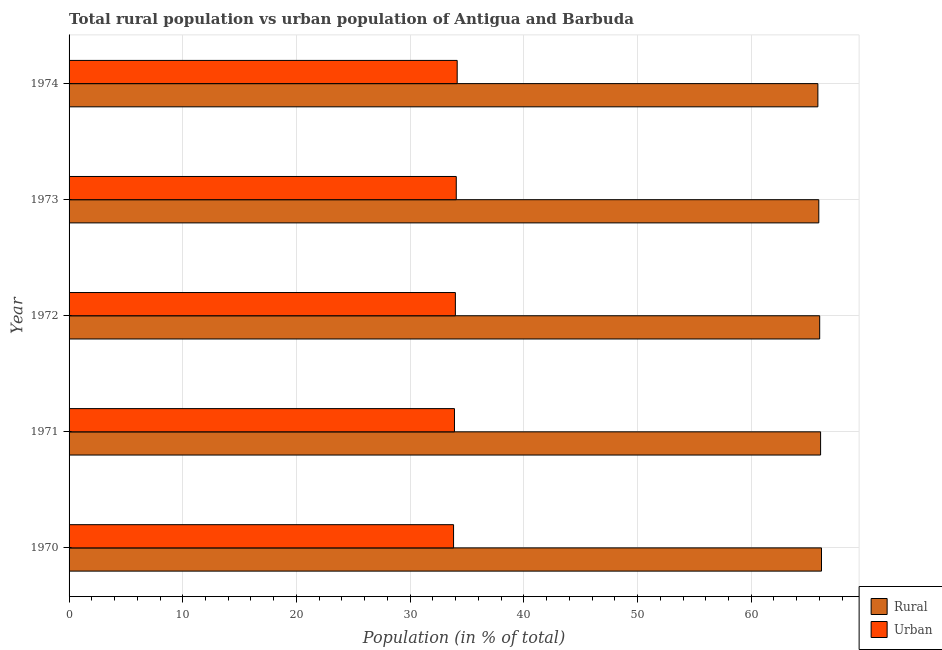How many different coloured bars are there?
Make the answer very short. 2. How many groups of bars are there?
Your response must be concise. 5. Are the number of bars per tick equal to the number of legend labels?
Your answer should be very brief. Yes. Are the number of bars on each tick of the Y-axis equal?
Provide a succinct answer. Yes. How many bars are there on the 1st tick from the top?
Give a very brief answer. 2. How many bars are there on the 1st tick from the bottom?
Provide a short and direct response. 2. What is the rural population in 1973?
Your answer should be compact. 65.94. Across all years, what is the maximum rural population?
Provide a succinct answer. 66.18. Across all years, what is the minimum urban population?
Your answer should be compact. 33.82. In which year was the urban population maximum?
Provide a short and direct response. 1974. In which year was the rural population minimum?
Offer a very short reply. 1974. What is the total rural population in the graph?
Offer a very short reply. 330.11. What is the difference between the rural population in 1971 and that in 1974?
Your response must be concise. 0.24. What is the difference between the rural population in 1972 and the urban population in 1973?
Give a very brief answer. 31.96. What is the average rural population per year?
Keep it short and to the point. 66.02. In the year 1972, what is the difference between the urban population and rural population?
Keep it short and to the point. -32.04. What is the ratio of the rural population in 1970 to that in 1973?
Your answer should be compact. 1. Is the rural population in 1970 less than that in 1974?
Keep it short and to the point. No. What is the difference between the highest and the second highest rural population?
Offer a very short reply. 0.08. What is the difference between the highest and the lowest urban population?
Your answer should be very brief. 0.32. What does the 1st bar from the top in 1970 represents?
Provide a succinct answer. Urban. What does the 1st bar from the bottom in 1972 represents?
Your answer should be very brief. Rural. How many bars are there?
Provide a short and direct response. 10. Are all the bars in the graph horizontal?
Keep it short and to the point. Yes. What is the difference between two consecutive major ticks on the X-axis?
Provide a succinct answer. 10. How are the legend labels stacked?
Offer a very short reply. Vertical. What is the title of the graph?
Ensure brevity in your answer.  Total rural population vs urban population of Antigua and Barbuda. What is the label or title of the X-axis?
Make the answer very short. Population (in % of total). What is the label or title of the Y-axis?
Make the answer very short. Year. What is the Population (in % of total) of Rural in 1970?
Provide a succinct answer. 66.18. What is the Population (in % of total) of Urban in 1970?
Make the answer very short. 33.82. What is the Population (in % of total) of Rural in 1971?
Make the answer very short. 66.1. What is the Population (in % of total) in Urban in 1971?
Your response must be concise. 33.9. What is the Population (in % of total) of Rural in 1972?
Make the answer very short. 66.02. What is the Population (in % of total) of Urban in 1972?
Offer a terse response. 33.98. What is the Population (in % of total) of Rural in 1973?
Give a very brief answer. 65.94. What is the Population (in % of total) in Urban in 1973?
Provide a short and direct response. 34.06. What is the Population (in % of total) of Rural in 1974?
Provide a short and direct response. 65.86. What is the Population (in % of total) in Urban in 1974?
Your answer should be very brief. 34.14. Across all years, what is the maximum Population (in % of total) of Rural?
Offer a very short reply. 66.18. Across all years, what is the maximum Population (in % of total) in Urban?
Offer a very short reply. 34.14. Across all years, what is the minimum Population (in % of total) of Rural?
Offer a very short reply. 65.86. Across all years, what is the minimum Population (in % of total) in Urban?
Make the answer very short. 33.82. What is the total Population (in % of total) of Rural in the graph?
Your response must be concise. 330.11. What is the total Population (in % of total) of Urban in the graph?
Make the answer very short. 169.89. What is the difference between the Population (in % of total) in Rural in 1970 and that in 1971?
Your answer should be compact. 0.08. What is the difference between the Population (in % of total) of Urban in 1970 and that in 1971?
Your answer should be compact. -0.08. What is the difference between the Population (in % of total) in Rural in 1970 and that in 1972?
Provide a succinct answer. 0.16. What is the difference between the Population (in % of total) in Urban in 1970 and that in 1972?
Offer a very short reply. -0.16. What is the difference between the Population (in % of total) in Rural in 1970 and that in 1973?
Your answer should be compact. 0.24. What is the difference between the Population (in % of total) of Urban in 1970 and that in 1973?
Ensure brevity in your answer.  -0.24. What is the difference between the Population (in % of total) of Rural in 1970 and that in 1974?
Your answer should be very brief. 0.32. What is the difference between the Population (in % of total) in Urban in 1970 and that in 1974?
Make the answer very short. -0.32. What is the difference between the Population (in % of total) in Rural in 1971 and that in 1972?
Provide a short and direct response. 0.08. What is the difference between the Population (in % of total) of Urban in 1971 and that in 1972?
Offer a very short reply. -0.08. What is the difference between the Population (in % of total) in Rural in 1971 and that in 1973?
Make the answer very short. 0.16. What is the difference between the Population (in % of total) in Urban in 1971 and that in 1973?
Make the answer very short. -0.16. What is the difference between the Population (in % of total) of Rural in 1971 and that in 1974?
Give a very brief answer. 0.24. What is the difference between the Population (in % of total) in Urban in 1971 and that in 1974?
Your answer should be very brief. -0.24. What is the difference between the Population (in % of total) in Rural in 1972 and that in 1973?
Give a very brief answer. 0.08. What is the difference between the Population (in % of total) of Urban in 1972 and that in 1973?
Give a very brief answer. -0.08. What is the difference between the Population (in % of total) in Rural in 1972 and that in 1974?
Give a very brief answer. 0.16. What is the difference between the Population (in % of total) of Urban in 1972 and that in 1974?
Give a very brief answer. -0.16. What is the difference between the Population (in % of total) of Urban in 1973 and that in 1974?
Offer a terse response. -0.08. What is the difference between the Population (in % of total) of Rural in 1970 and the Population (in % of total) of Urban in 1971?
Make the answer very short. 32.28. What is the difference between the Population (in % of total) in Rural in 1970 and the Population (in % of total) in Urban in 1972?
Offer a very short reply. 32.2. What is the difference between the Population (in % of total) of Rural in 1970 and the Population (in % of total) of Urban in 1973?
Ensure brevity in your answer.  32.12. What is the difference between the Population (in % of total) in Rural in 1970 and the Population (in % of total) in Urban in 1974?
Your answer should be very brief. 32.04. What is the difference between the Population (in % of total) of Rural in 1971 and the Population (in % of total) of Urban in 1972?
Offer a very short reply. 32.12. What is the difference between the Population (in % of total) in Rural in 1971 and the Population (in % of total) in Urban in 1973?
Give a very brief answer. 32.05. What is the difference between the Population (in % of total) in Rural in 1971 and the Population (in % of total) in Urban in 1974?
Your response must be concise. 31.96. What is the difference between the Population (in % of total) of Rural in 1972 and the Population (in % of total) of Urban in 1973?
Keep it short and to the point. 31.96. What is the difference between the Population (in % of total) in Rural in 1972 and the Population (in % of total) in Urban in 1974?
Offer a terse response. 31.89. What is the difference between the Population (in % of total) of Rural in 1973 and the Population (in % of total) of Urban in 1974?
Your answer should be very brief. 31.81. What is the average Population (in % of total) of Rural per year?
Your answer should be very brief. 66.02. What is the average Population (in % of total) of Urban per year?
Offer a terse response. 33.98. In the year 1970, what is the difference between the Population (in % of total) of Rural and Population (in % of total) of Urban?
Your response must be concise. 32.36. In the year 1971, what is the difference between the Population (in % of total) in Rural and Population (in % of total) in Urban?
Offer a terse response. 32.2. In the year 1972, what is the difference between the Population (in % of total) in Rural and Population (in % of total) in Urban?
Provide a succinct answer. 32.04. In the year 1973, what is the difference between the Population (in % of total) of Rural and Population (in % of total) of Urban?
Keep it short and to the point. 31.89. In the year 1974, what is the difference between the Population (in % of total) of Rural and Population (in % of total) of Urban?
Provide a succinct answer. 31.73. What is the ratio of the Population (in % of total) in Urban in 1970 to that in 1971?
Provide a succinct answer. 1. What is the ratio of the Population (in % of total) of Rural in 1970 to that in 1972?
Your response must be concise. 1. What is the ratio of the Population (in % of total) in Urban in 1970 to that in 1972?
Make the answer very short. 1. What is the ratio of the Population (in % of total) in Rural in 1970 to that in 1973?
Your response must be concise. 1. What is the ratio of the Population (in % of total) of Urban in 1970 to that in 1973?
Your answer should be compact. 0.99. What is the ratio of the Population (in % of total) in Rural in 1970 to that in 1974?
Ensure brevity in your answer.  1. What is the ratio of the Population (in % of total) of Urban in 1971 to that in 1972?
Offer a terse response. 1. What is the ratio of the Population (in % of total) of Rural in 1971 to that in 1973?
Offer a very short reply. 1. What is the ratio of the Population (in % of total) in Rural in 1971 to that in 1974?
Your response must be concise. 1. What is the ratio of the Population (in % of total) in Urban in 1971 to that in 1974?
Your response must be concise. 0.99. What is the ratio of the Population (in % of total) in Rural in 1972 to that in 1974?
Keep it short and to the point. 1. What is the ratio of the Population (in % of total) of Urban in 1972 to that in 1974?
Your response must be concise. 1. What is the ratio of the Population (in % of total) of Rural in 1973 to that in 1974?
Keep it short and to the point. 1. What is the ratio of the Population (in % of total) of Urban in 1973 to that in 1974?
Ensure brevity in your answer.  1. What is the difference between the highest and the second highest Population (in % of total) in Rural?
Provide a short and direct response. 0.08. What is the difference between the highest and the second highest Population (in % of total) of Urban?
Your answer should be compact. 0.08. What is the difference between the highest and the lowest Population (in % of total) in Rural?
Ensure brevity in your answer.  0.32. What is the difference between the highest and the lowest Population (in % of total) in Urban?
Provide a succinct answer. 0.32. 